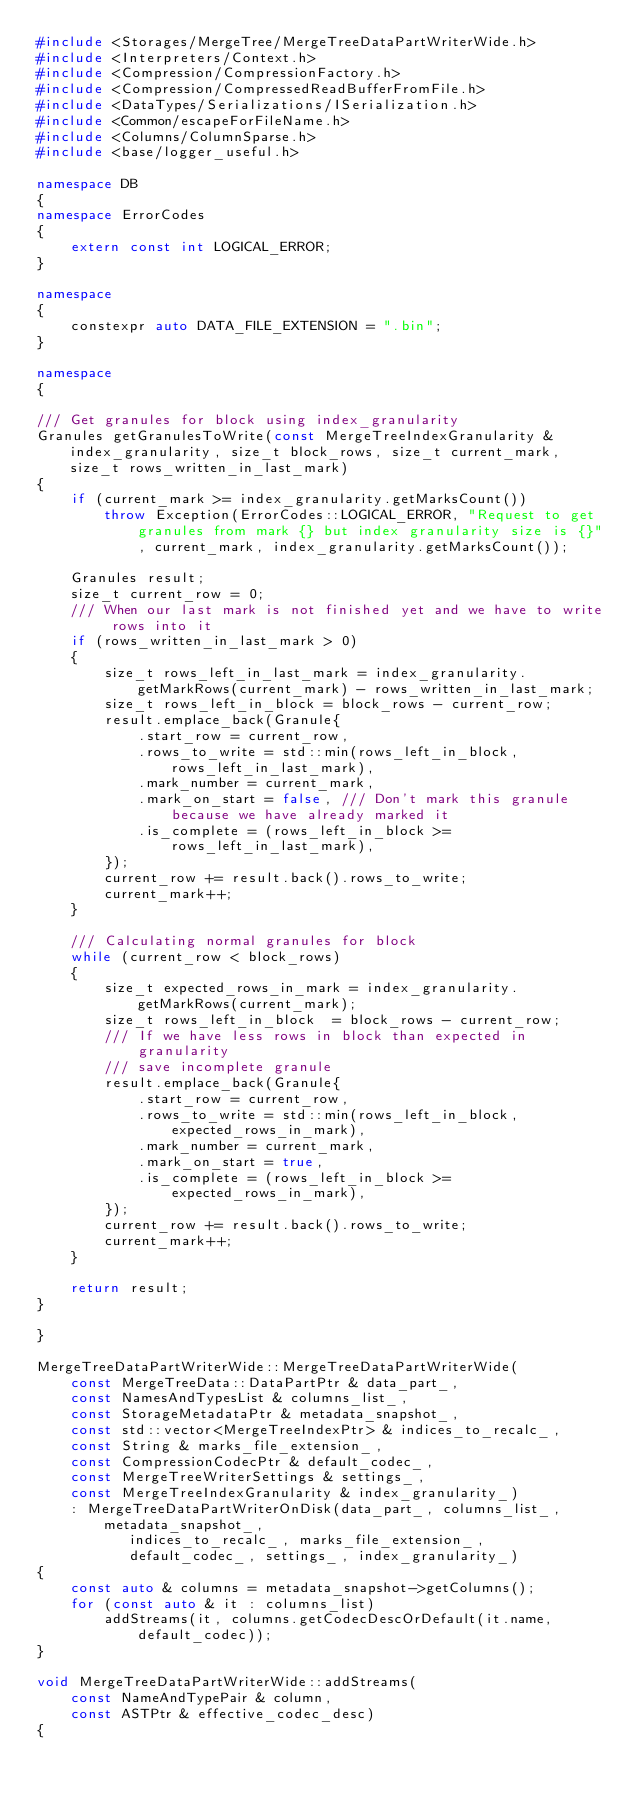<code> <loc_0><loc_0><loc_500><loc_500><_C++_>#include <Storages/MergeTree/MergeTreeDataPartWriterWide.h>
#include <Interpreters/Context.h>
#include <Compression/CompressionFactory.h>
#include <Compression/CompressedReadBufferFromFile.h>
#include <DataTypes/Serializations/ISerialization.h>
#include <Common/escapeForFileName.h>
#include <Columns/ColumnSparse.h>
#include <base/logger_useful.h>

namespace DB
{
namespace ErrorCodes
{
    extern const int LOGICAL_ERROR;
}

namespace
{
    constexpr auto DATA_FILE_EXTENSION = ".bin";
}

namespace
{

/// Get granules for block using index_granularity
Granules getGranulesToWrite(const MergeTreeIndexGranularity & index_granularity, size_t block_rows, size_t current_mark, size_t rows_written_in_last_mark)
{
    if (current_mark >= index_granularity.getMarksCount())
        throw Exception(ErrorCodes::LOGICAL_ERROR, "Request to get granules from mark {} but index granularity size is {}", current_mark, index_granularity.getMarksCount());

    Granules result;
    size_t current_row = 0;
    /// When our last mark is not finished yet and we have to write rows into it
    if (rows_written_in_last_mark > 0)
    {
        size_t rows_left_in_last_mark = index_granularity.getMarkRows(current_mark) - rows_written_in_last_mark;
        size_t rows_left_in_block = block_rows - current_row;
        result.emplace_back(Granule{
            .start_row = current_row,
            .rows_to_write = std::min(rows_left_in_block, rows_left_in_last_mark),
            .mark_number = current_mark,
            .mark_on_start = false, /// Don't mark this granule because we have already marked it
            .is_complete = (rows_left_in_block >= rows_left_in_last_mark),
        });
        current_row += result.back().rows_to_write;
        current_mark++;
    }

    /// Calculating normal granules for block
    while (current_row < block_rows)
    {
        size_t expected_rows_in_mark = index_granularity.getMarkRows(current_mark);
        size_t rows_left_in_block  = block_rows - current_row;
        /// If we have less rows in block than expected in granularity
        /// save incomplete granule
        result.emplace_back(Granule{
            .start_row = current_row,
            .rows_to_write = std::min(rows_left_in_block, expected_rows_in_mark),
            .mark_number = current_mark,
            .mark_on_start = true,
            .is_complete = (rows_left_in_block >= expected_rows_in_mark),
        });
        current_row += result.back().rows_to_write;
        current_mark++;
    }

    return result;
}

}

MergeTreeDataPartWriterWide::MergeTreeDataPartWriterWide(
    const MergeTreeData::DataPartPtr & data_part_,
    const NamesAndTypesList & columns_list_,
    const StorageMetadataPtr & metadata_snapshot_,
    const std::vector<MergeTreeIndexPtr> & indices_to_recalc_,
    const String & marks_file_extension_,
    const CompressionCodecPtr & default_codec_,
    const MergeTreeWriterSettings & settings_,
    const MergeTreeIndexGranularity & index_granularity_)
    : MergeTreeDataPartWriterOnDisk(data_part_, columns_list_, metadata_snapshot_,
           indices_to_recalc_, marks_file_extension_,
           default_codec_, settings_, index_granularity_)
{
    const auto & columns = metadata_snapshot->getColumns();
    for (const auto & it : columns_list)
        addStreams(it, columns.getCodecDescOrDefault(it.name, default_codec));
}

void MergeTreeDataPartWriterWide::addStreams(
    const NameAndTypePair & column,
    const ASTPtr & effective_codec_desc)
{</code> 